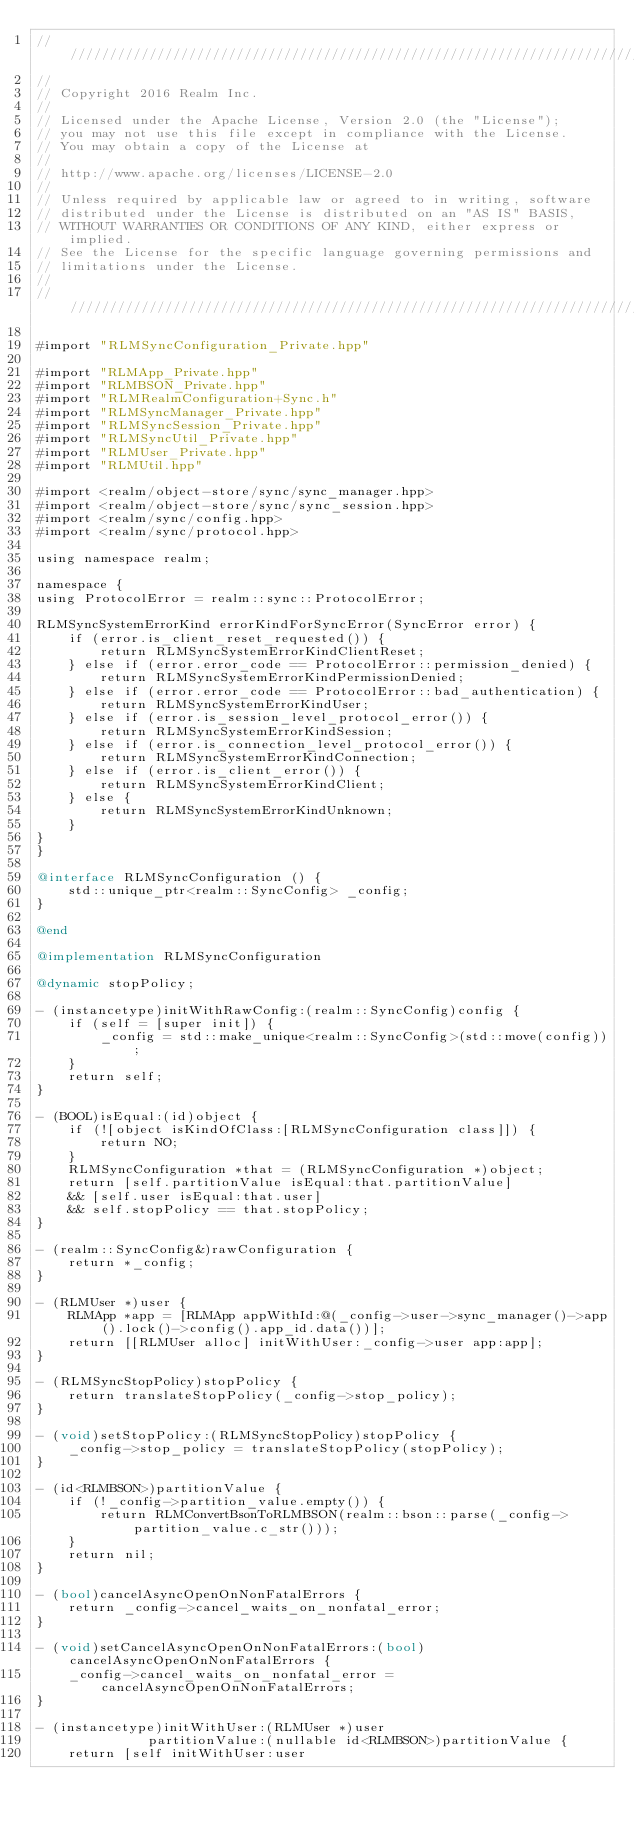Convert code to text. <code><loc_0><loc_0><loc_500><loc_500><_ObjectiveC_>////////////////////////////////////////////////////////////////////////////
//
// Copyright 2016 Realm Inc.
//
// Licensed under the Apache License, Version 2.0 (the "License");
// you may not use this file except in compliance with the License.
// You may obtain a copy of the License at
//
// http://www.apache.org/licenses/LICENSE-2.0
//
// Unless required by applicable law or agreed to in writing, software
// distributed under the License is distributed on an "AS IS" BASIS,
// WITHOUT WARRANTIES OR CONDITIONS OF ANY KIND, either express or implied.
// See the License for the specific language governing permissions and
// limitations under the License.
//
////////////////////////////////////////////////////////////////////////////

#import "RLMSyncConfiguration_Private.hpp"

#import "RLMApp_Private.hpp"
#import "RLMBSON_Private.hpp"
#import "RLMRealmConfiguration+Sync.h"
#import "RLMSyncManager_Private.hpp"
#import "RLMSyncSession_Private.hpp"
#import "RLMSyncUtil_Private.hpp"
#import "RLMUser_Private.hpp"
#import "RLMUtil.hpp"

#import <realm/object-store/sync/sync_manager.hpp>
#import <realm/object-store/sync/sync_session.hpp>
#import <realm/sync/config.hpp>
#import <realm/sync/protocol.hpp>

using namespace realm;

namespace {
using ProtocolError = realm::sync::ProtocolError;

RLMSyncSystemErrorKind errorKindForSyncError(SyncError error) {
    if (error.is_client_reset_requested()) {
        return RLMSyncSystemErrorKindClientReset;
    } else if (error.error_code == ProtocolError::permission_denied) {
        return RLMSyncSystemErrorKindPermissionDenied;
    } else if (error.error_code == ProtocolError::bad_authentication) {
        return RLMSyncSystemErrorKindUser;
    } else if (error.is_session_level_protocol_error()) {
        return RLMSyncSystemErrorKindSession;
    } else if (error.is_connection_level_protocol_error()) {
        return RLMSyncSystemErrorKindConnection;
    } else if (error.is_client_error()) {
        return RLMSyncSystemErrorKindClient;
    } else {
        return RLMSyncSystemErrorKindUnknown;
    }
}
}

@interface RLMSyncConfiguration () {
    std::unique_ptr<realm::SyncConfig> _config;
}

@end

@implementation RLMSyncConfiguration

@dynamic stopPolicy;

- (instancetype)initWithRawConfig:(realm::SyncConfig)config {
    if (self = [super init]) {
        _config = std::make_unique<realm::SyncConfig>(std::move(config));
    }
    return self;
}

- (BOOL)isEqual:(id)object {
    if (![object isKindOfClass:[RLMSyncConfiguration class]]) {
        return NO;
    }
    RLMSyncConfiguration *that = (RLMSyncConfiguration *)object;
    return [self.partitionValue isEqual:that.partitionValue]
    && [self.user isEqual:that.user]
    && self.stopPolicy == that.stopPolicy;
}

- (realm::SyncConfig&)rawConfiguration {
    return *_config;
}

- (RLMUser *)user {
    RLMApp *app = [RLMApp appWithId:@(_config->user->sync_manager()->app().lock()->config().app_id.data())];
    return [[RLMUser alloc] initWithUser:_config->user app:app];
}

- (RLMSyncStopPolicy)stopPolicy {
    return translateStopPolicy(_config->stop_policy);
}

- (void)setStopPolicy:(RLMSyncStopPolicy)stopPolicy {
    _config->stop_policy = translateStopPolicy(stopPolicy);
}

- (id<RLMBSON>)partitionValue {
    if (!_config->partition_value.empty()) {
        return RLMConvertBsonToRLMBSON(realm::bson::parse(_config->partition_value.c_str()));
    }
    return nil;
}

- (bool)cancelAsyncOpenOnNonFatalErrors {
    return _config->cancel_waits_on_nonfatal_error;
}

- (void)setCancelAsyncOpenOnNonFatalErrors:(bool)cancelAsyncOpenOnNonFatalErrors {
    _config->cancel_waits_on_nonfatal_error = cancelAsyncOpenOnNonFatalErrors;
}

- (instancetype)initWithUser:(RLMUser *)user
              partitionValue:(nullable id<RLMBSON>)partitionValue {
    return [self initWithUser:user</code> 